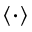<formula> <loc_0><loc_0><loc_500><loc_500>\langle \cdot \rangle</formula> 